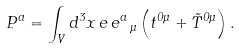<formula> <loc_0><loc_0><loc_500><loc_500>P ^ { a } = \int _ { V } d ^ { 3 } x \, e \, e ^ { a } \, _ { \mu } \left ( t ^ { 0 \mu } + \tilde { T } ^ { 0 \mu } \right ) .</formula> 